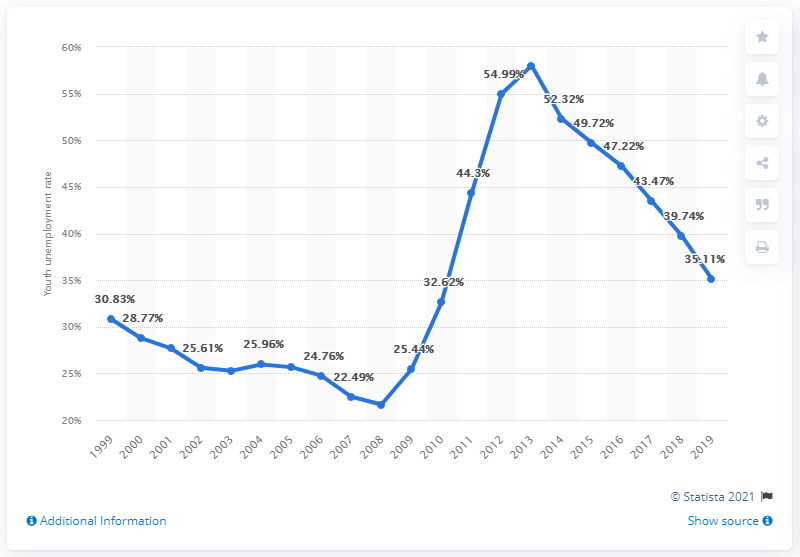Highlight a few significant elements in this photo. In 2019, the youth unemployment rate in Greece was 35.11%. 